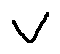Convert formula to latex. <formula><loc_0><loc_0><loc_500><loc_500>v</formula> 